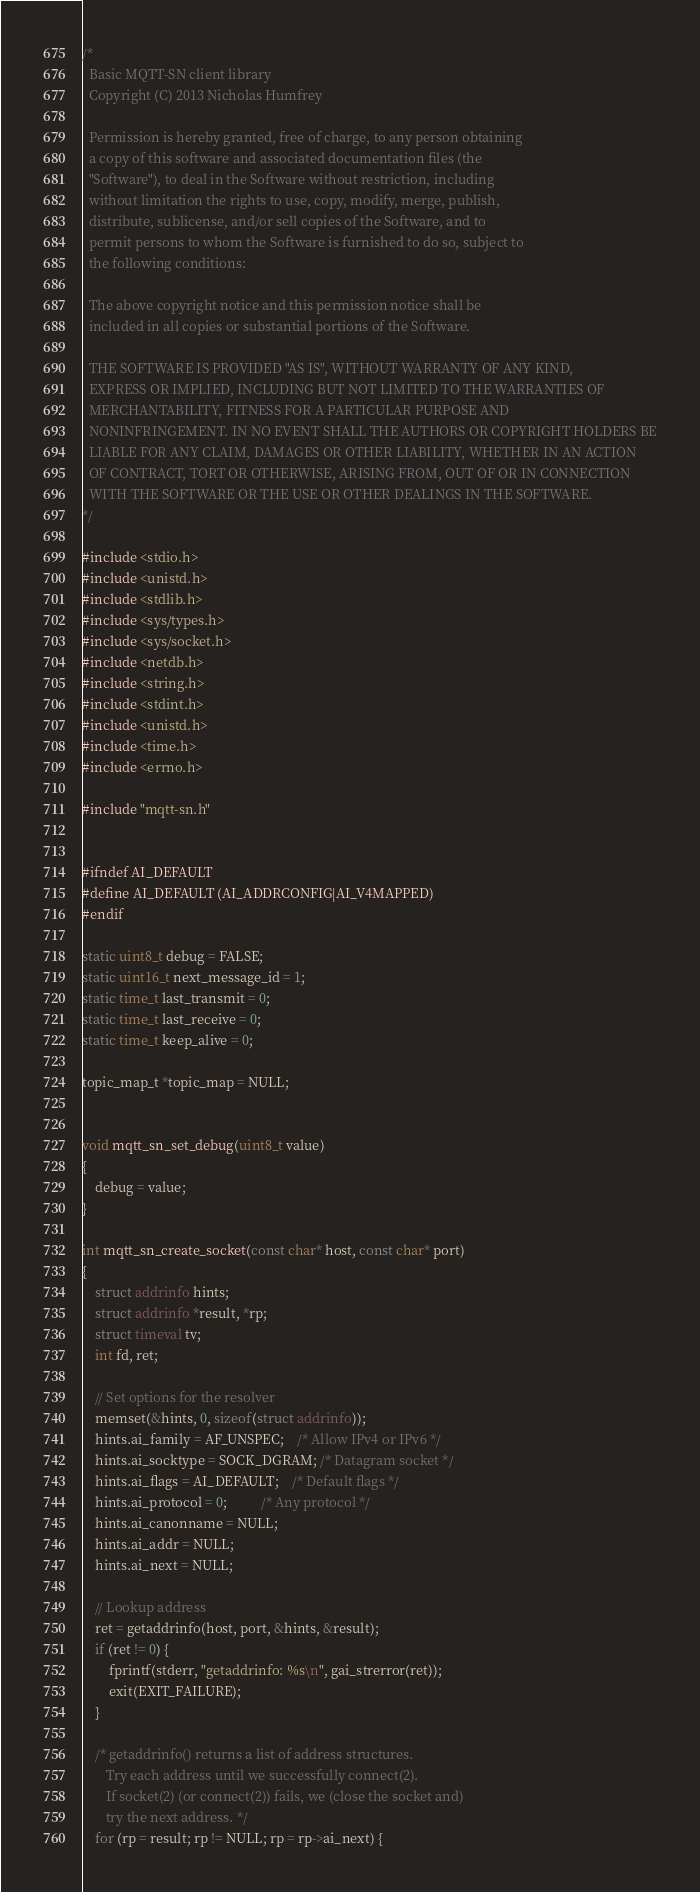<code> <loc_0><loc_0><loc_500><loc_500><_C_>/*
  Basic MQTT-SN client library
  Copyright (C) 2013 Nicholas Humfrey

  Permission is hereby granted, free of charge, to any person obtaining
  a copy of this software and associated documentation files (the
  "Software"), to deal in the Software without restriction, including
  without limitation the rights to use, copy, modify, merge, publish,
  distribute, sublicense, and/or sell copies of the Software, and to
  permit persons to whom the Software is furnished to do so, subject to
  the following conditions:

  The above copyright notice and this permission notice shall be
  included in all copies or substantial portions of the Software.

  THE SOFTWARE IS PROVIDED "AS IS", WITHOUT WARRANTY OF ANY KIND,
  EXPRESS OR IMPLIED, INCLUDING BUT NOT LIMITED TO THE WARRANTIES OF
  MERCHANTABILITY, FITNESS FOR A PARTICULAR PURPOSE AND
  NONINFRINGEMENT. IN NO EVENT SHALL THE AUTHORS OR COPYRIGHT HOLDERS BE
  LIABLE FOR ANY CLAIM, DAMAGES OR OTHER LIABILITY, WHETHER IN AN ACTION
  OF CONTRACT, TORT OR OTHERWISE, ARISING FROM, OUT OF OR IN CONNECTION
  WITH THE SOFTWARE OR THE USE OR OTHER DEALINGS IN THE SOFTWARE.
*/

#include <stdio.h>
#include <unistd.h>
#include <stdlib.h>
#include <sys/types.h>
#include <sys/socket.h>
#include <netdb.h>
#include <string.h>
#include <stdint.h>
#include <unistd.h>
#include <time.h>
#include <errno.h>

#include "mqtt-sn.h"


#ifndef AI_DEFAULT
#define AI_DEFAULT (AI_ADDRCONFIG|AI_V4MAPPED)
#endif

static uint8_t debug = FALSE;
static uint16_t next_message_id = 1;
static time_t last_transmit = 0;
static time_t last_receive = 0;
static time_t keep_alive = 0;

topic_map_t *topic_map = NULL;


void mqtt_sn_set_debug(uint8_t value)
{
    debug = value;
}

int mqtt_sn_create_socket(const char* host, const char* port)
{
    struct addrinfo hints;
    struct addrinfo *result, *rp;
    struct timeval tv;
    int fd, ret;

    // Set options for the resolver
    memset(&hints, 0, sizeof(struct addrinfo));
    hints.ai_family = AF_UNSPEC;    /* Allow IPv4 or IPv6 */
    hints.ai_socktype = SOCK_DGRAM; /* Datagram socket */
    hints.ai_flags = AI_DEFAULT;    /* Default flags */
    hints.ai_protocol = 0;          /* Any protocol */
    hints.ai_canonname = NULL;
    hints.ai_addr = NULL;
    hints.ai_next = NULL;

    // Lookup address
    ret = getaddrinfo(host, port, &hints, &result);
    if (ret != 0) {
        fprintf(stderr, "getaddrinfo: %s\n", gai_strerror(ret));
        exit(EXIT_FAILURE);
    }

    /* getaddrinfo() returns a list of address structures.
       Try each address until we successfully connect(2).
       If socket(2) (or connect(2)) fails, we (close the socket and)
       try the next address. */
    for (rp = result; rp != NULL; rp = rp->ai_next) {</code> 